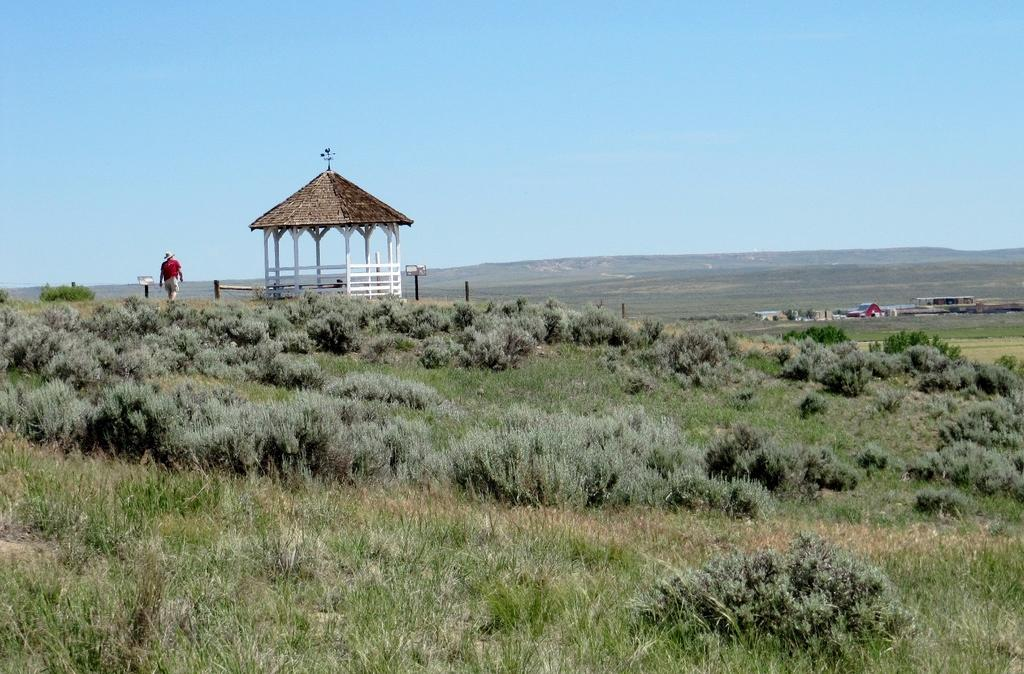What type of vegetation is present in the image? There is grass in the image. Where is the person located in the image? The person is on the left side of the image. What structure is also located on the left side of the image? There is a hut on the left side of the image. What can be seen in the sky in the background of the image? There are clouds in the sky in the background of the image. How many dolls are present in the image? There are no dolls present in the image. Where is the park located in the image? There is no park present in the image. 